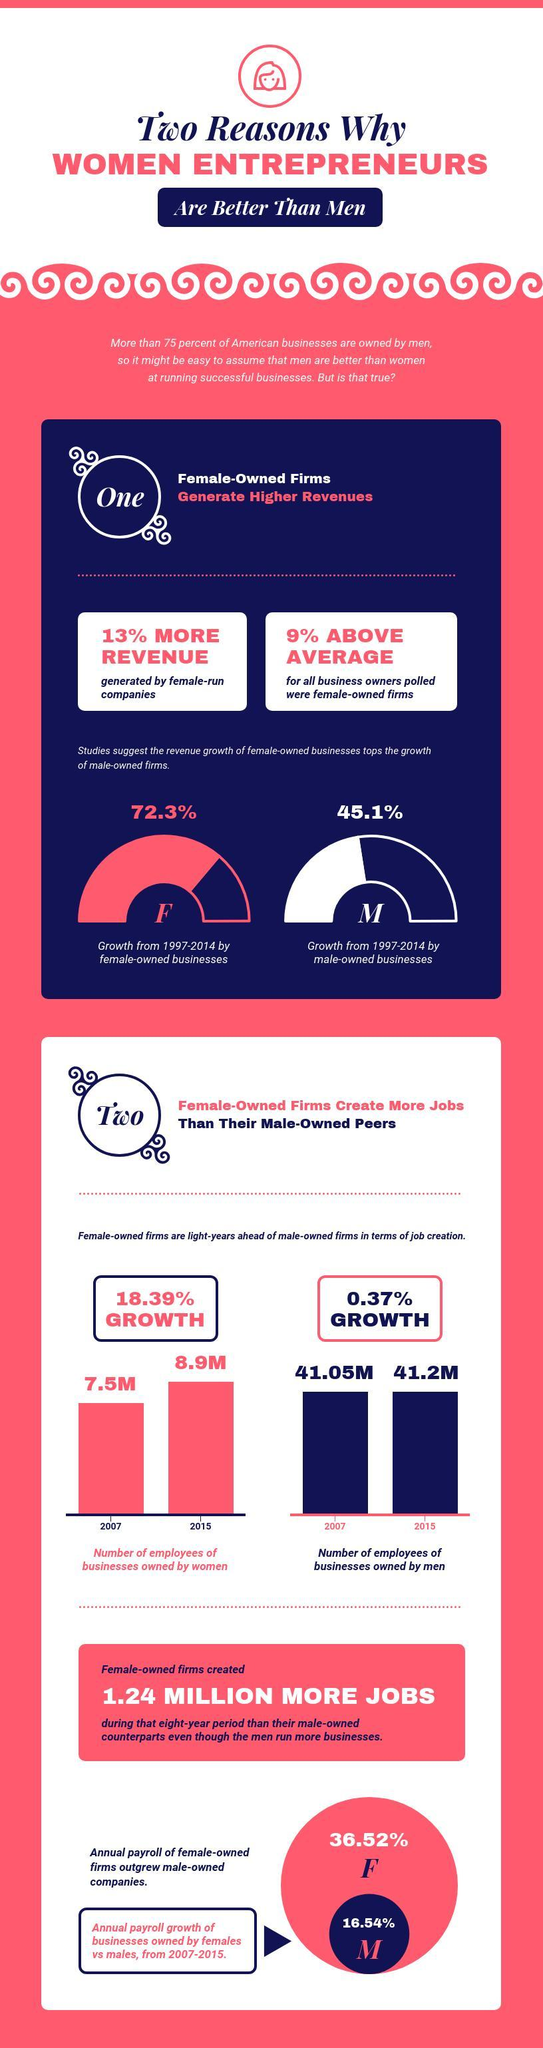Who had a higher percentage of annual pay roll in business, females or males?
Answer the question with a short phrase. females By what percentage do women owned firms beat the male owned firms in job creation? 18.02% What is the percentage difference in revenue of female and male owned business? 27.2% 